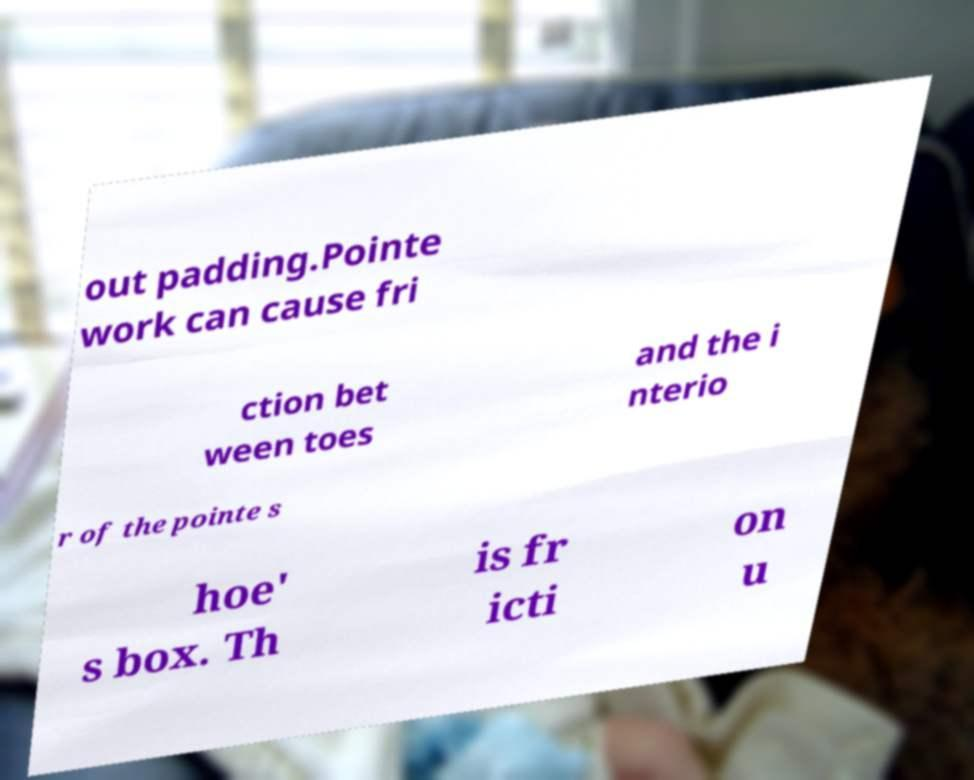What messages or text are displayed in this image? I need them in a readable, typed format. out padding.Pointe work can cause fri ction bet ween toes and the i nterio r of the pointe s hoe' s box. Th is fr icti on u 